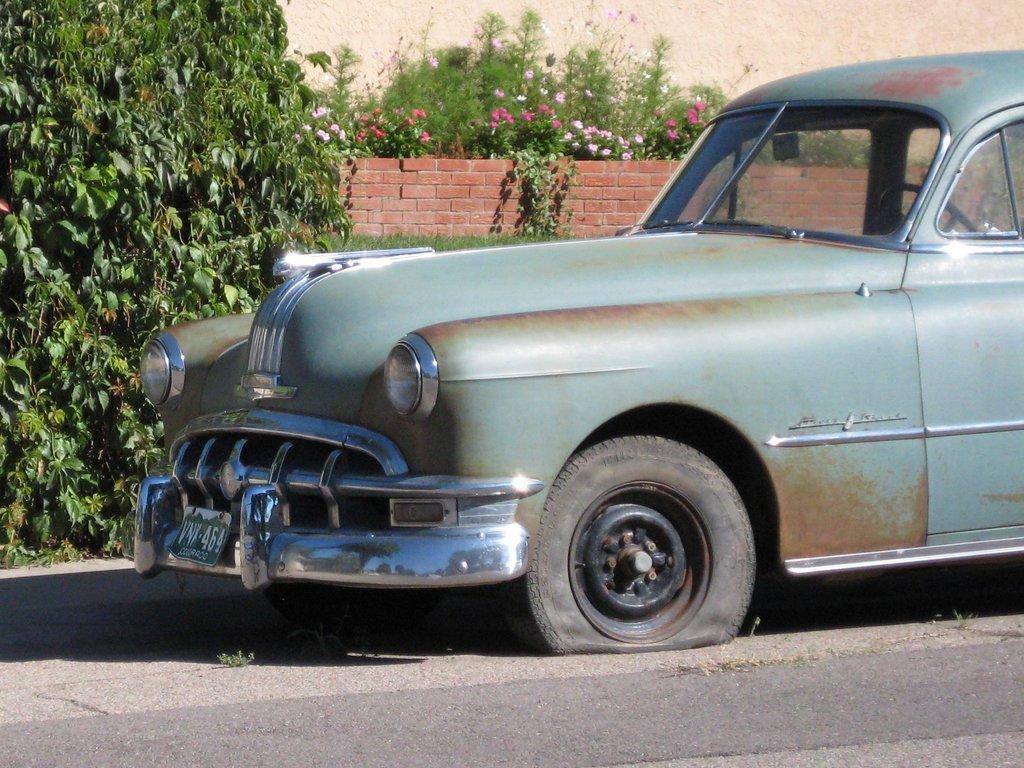What is the condition of the car in the image? The car has a punctured tyre in the image. Where is the car located? The car is on the road in the image. What can be seen in the background of the image? There is a tree, plants, a brick wall, and a plain wall in the background of the image. What type of transport does the achiever use to reach the moon in the image? There is no achiever or moon present in the image; it features a car with a punctured tyre on the road. 